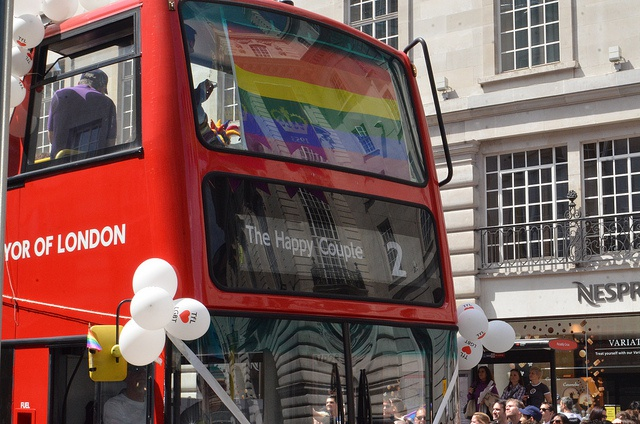Describe the objects in this image and their specific colors. I can see bus in black, gray, red, and maroon tones, people in black and gray tones, people in black and gray tones, people in black, gray, and darkblue tones, and people in black, gray, and maroon tones in this image. 